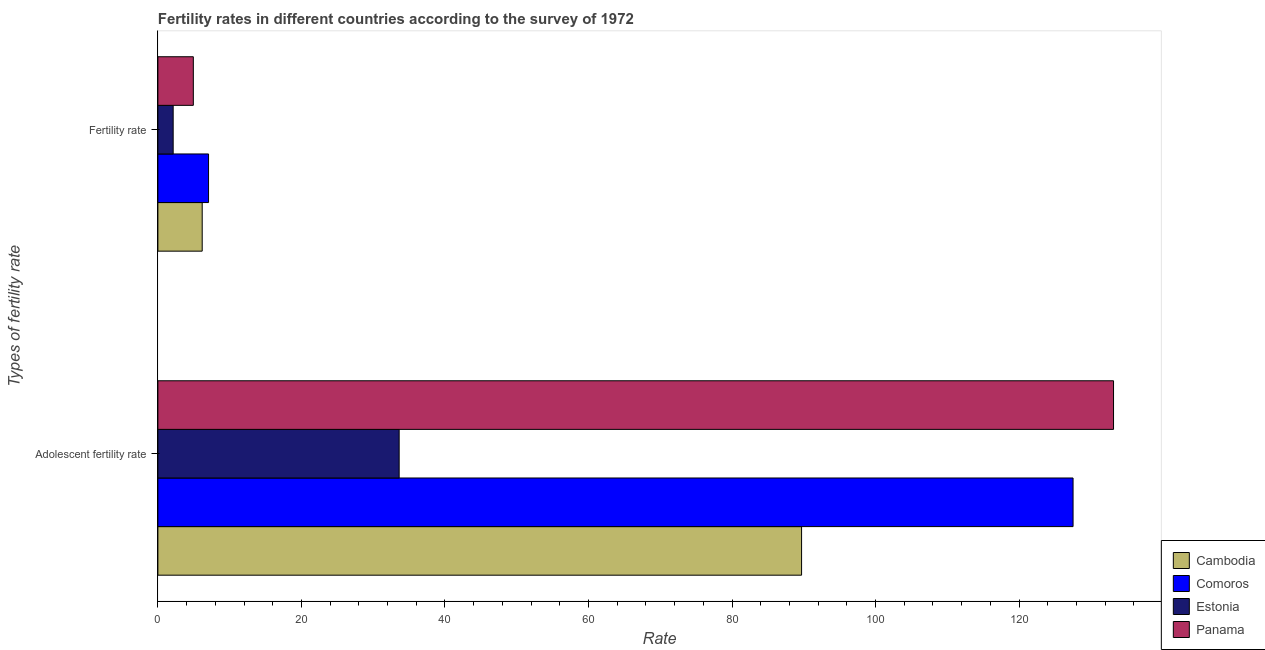How many different coloured bars are there?
Your answer should be very brief. 4. How many groups of bars are there?
Offer a very short reply. 2. Are the number of bars on each tick of the Y-axis equal?
Your answer should be compact. Yes. What is the label of the 2nd group of bars from the top?
Offer a very short reply. Adolescent fertility rate. What is the adolescent fertility rate in Comoros?
Provide a succinct answer. 127.52. Across all countries, what is the maximum adolescent fertility rate?
Provide a succinct answer. 133.16. Across all countries, what is the minimum fertility rate?
Your response must be concise. 2.13. In which country was the fertility rate maximum?
Offer a very short reply. Comoros. In which country was the adolescent fertility rate minimum?
Your answer should be very brief. Estonia. What is the total fertility rate in the graph?
Ensure brevity in your answer.  20.3. What is the difference between the adolescent fertility rate in Comoros and that in Cambodia?
Your response must be concise. 37.83. What is the difference between the adolescent fertility rate in Panama and the fertility rate in Estonia?
Provide a short and direct response. 131.03. What is the average fertility rate per country?
Offer a very short reply. 5.08. What is the difference between the adolescent fertility rate and fertility rate in Panama?
Make the answer very short. 128.22. What is the ratio of the fertility rate in Comoros to that in Estonia?
Offer a terse response. 3.31. Is the adolescent fertility rate in Cambodia less than that in Comoros?
Your response must be concise. Yes. In how many countries, is the adolescent fertility rate greater than the average adolescent fertility rate taken over all countries?
Provide a short and direct response. 2. What does the 2nd bar from the top in Fertility rate represents?
Offer a terse response. Estonia. What does the 2nd bar from the bottom in Adolescent fertility rate represents?
Offer a terse response. Comoros. How many bars are there?
Provide a succinct answer. 8. Are the values on the major ticks of X-axis written in scientific E-notation?
Offer a very short reply. No. Does the graph contain grids?
Your response must be concise. No. What is the title of the graph?
Ensure brevity in your answer.  Fertility rates in different countries according to the survey of 1972. What is the label or title of the X-axis?
Make the answer very short. Rate. What is the label or title of the Y-axis?
Your answer should be compact. Types of fertility rate. What is the Rate in Cambodia in Adolescent fertility rate?
Provide a succinct answer. 89.69. What is the Rate in Comoros in Adolescent fertility rate?
Offer a very short reply. 127.52. What is the Rate of Estonia in Adolescent fertility rate?
Keep it short and to the point. 33.62. What is the Rate in Panama in Adolescent fertility rate?
Provide a succinct answer. 133.16. What is the Rate of Cambodia in Fertility rate?
Offer a terse response. 6.17. What is the Rate in Comoros in Fertility rate?
Provide a short and direct response. 7.06. What is the Rate in Estonia in Fertility rate?
Make the answer very short. 2.13. What is the Rate in Panama in Fertility rate?
Keep it short and to the point. 4.94. Across all Types of fertility rate, what is the maximum Rate in Cambodia?
Your response must be concise. 89.69. Across all Types of fertility rate, what is the maximum Rate in Comoros?
Make the answer very short. 127.52. Across all Types of fertility rate, what is the maximum Rate of Estonia?
Your response must be concise. 33.62. Across all Types of fertility rate, what is the maximum Rate of Panama?
Offer a very short reply. 133.16. Across all Types of fertility rate, what is the minimum Rate of Cambodia?
Ensure brevity in your answer.  6.17. Across all Types of fertility rate, what is the minimum Rate in Comoros?
Your response must be concise. 7.06. Across all Types of fertility rate, what is the minimum Rate in Estonia?
Provide a succinct answer. 2.13. Across all Types of fertility rate, what is the minimum Rate of Panama?
Your answer should be very brief. 4.94. What is the total Rate in Cambodia in the graph?
Your answer should be compact. 95.86. What is the total Rate of Comoros in the graph?
Your answer should be compact. 134.58. What is the total Rate in Estonia in the graph?
Give a very brief answer. 35.75. What is the total Rate of Panama in the graph?
Offer a terse response. 138.1. What is the difference between the Rate in Cambodia in Adolescent fertility rate and that in Fertility rate?
Your answer should be very brief. 83.52. What is the difference between the Rate in Comoros in Adolescent fertility rate and that in Fertility rate?
Your answer should be very brief. 120.46. What is the difference between the Rate of Estonia in Adolescent fertility rate and that in Fertility rate?
Offer a terse response. 31.49. What is the difference between the Rate in Panama in Adolescent fertility rate and that in Fertility rate?
Offer a very short reply. 128.22. What is the difference between the Rate in Cambodia in Adolescent fertility rate and the Rate in Comoros in Fertility rate?
Give a very brief answer. 82.63. What is the difference between the Rate in Cambodia in Adolescent fertility rate and the Rate in Estonia in Fertility rate?
Ensure brevity in your answer.  87.56. What is the difference between the Rate in Cambodia in Adolescent fertility rate and the Rate in Panama in Fertility rate?
Give a very brief answer. 84.75. What is the difference between the Rate in Comoros in Adolescent fertility rate and the Rate in Estonia in Fertility rate?
Give a very brief answer. 125.39. What is the difference between the Rate in Comoros in Adolescent fertility rate and the Rate in Panama in Fertility rate?
Give a very brief answer. 122.58. What is the difference between the Rate in Estonia in Adolescent fertility rate and the Rate in Panama in Fertility rate?
Offer a terse response. 28.68. What is the average Rate of Cambodia per Types of fertility rate?
Provide a succinct answer. 47.93. What is the average Rate in Comoros per Types of fertility rate?
Your answer should be very brief. 67.29. What is the average Rate of Estonia per Types of fertility rate?
Make the answer very short. 17.87. What is the average Rate in Panama per Types of fertility rate?
Your answer should be compact. 69.05. What is the difference between the Rate of Cambodia and Rate of Comoros in Adolescent fertility rate?
Ensure brevity in your answer.  -37.83. What is the difference between the Rate of Cambodia and Rate of Estonia in Adolescent fertility rate?
Keep it short and to the point. 56.07. What is the difference between the Rate in Cambodia and Rate in Panama in Adolescent fertility rate?
Ensure brevity in your answer.  -43.47. What is the difference between the Rate of Comoros and Rate of Estonia in Adolescent fertility rate?
Keep it short and to the point. 93.9. What is the difference between the Rate of Comoros and Rate of Panama in Adolescent fertility rate?
Your answer should be compact. -5.64. What is the difference between the Rate of Estonia and Rate of Panama in Adolescent fertility rate?
Give a very brief answer. -99.54. What is the difference between the Rate in Cambodia and Rate in Comoros in Fertility rate?
Keep it short and to the point. -0.88. What is the difference between the Rate in Cambodia and Rate in Estonia in Fertility rate?
Give a very brief answer. 4.04. What is the difference between the Rate of Cambodia and Rate of Panama in Fertility rate?
Offer a terse response. 1.24. What is the difference between the Rate in Comoros and Rate in Estonia in Fertility rate?
Offer a terse response. 4.93. What is the difference between the Rate of Comoros and Rate of Panama in Fertility rate?
Offer a very short reply. 2.12. What is the difference between the Rate of Estonia and Rate of Panama in Fertility rate?
Keep it short and to the point. -2.81. What is the ratio of the Rate of Cambodia in Adolescent fertility rate to that in Fertility rate?
Make the answer very short. 14.52. What is the ratio of the Rate in Comoros in Adolescent fertility rate to that in Fertility rate?
Keep it short and to the point. 18.07. What is the ratio of the Rate in Estonia in Adolescent fertility rate to that in Fertility rate?
Your answer should be compact. 15.78. What is the ratio of the Rate of Panama in Adolescent fertility rate to that in Fertility rate?
Make the answer very short. 26.96. What is the difference between the highest and the second highest Rate in Cambodia?
Give a very brief answer. 83.52. What is the difference between the highest and the second highest Rate in Comoros?
Your answer should be compact. 120.46. What is the difference between the highest and the second highest Rate in Estonia?
Ensure brevity in your answer.  31.49. What is the difference between the highest and the second highest Rate of Panama?
Keep it short and to the point. 128.22. What is the difference between the highest and the lowest Rate of Cambodia?
Ensure brevity in your answer.  83.52. What is the difference between the highest and the lowest Rate in Comoros?
Offer a terse response. 120.46. What is the difference between the highest and the lowest Rate of Estonia?
Your answer should be very brief. 31.49. What is the difference between the highest and the lowest Rate of Panama?
Make the answer very short. 128.22. 